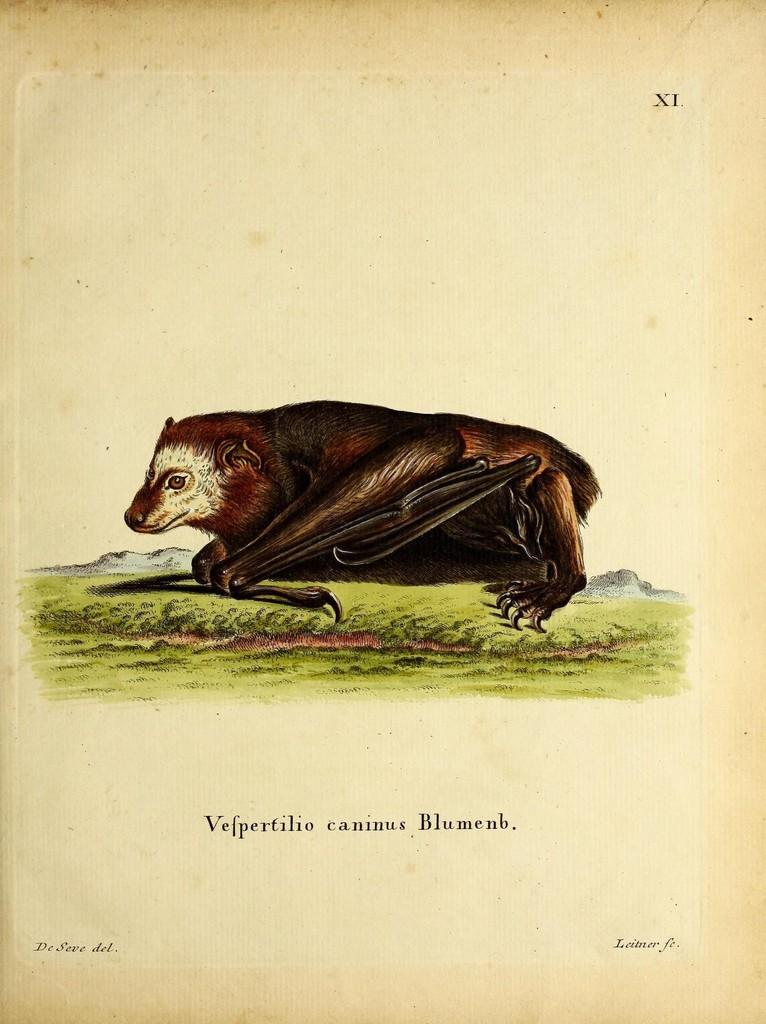What is present in the image that is related to visual communication? There is a poster in the image. What type of image is featured on the poster? The poster contains an image of an animal. What else can be found on the poster besides the image? There is text on the poster. What is the current weather like in the image? The provided facts do not mention any weather-related information, so it is impossible to determine the current weather from the image. 